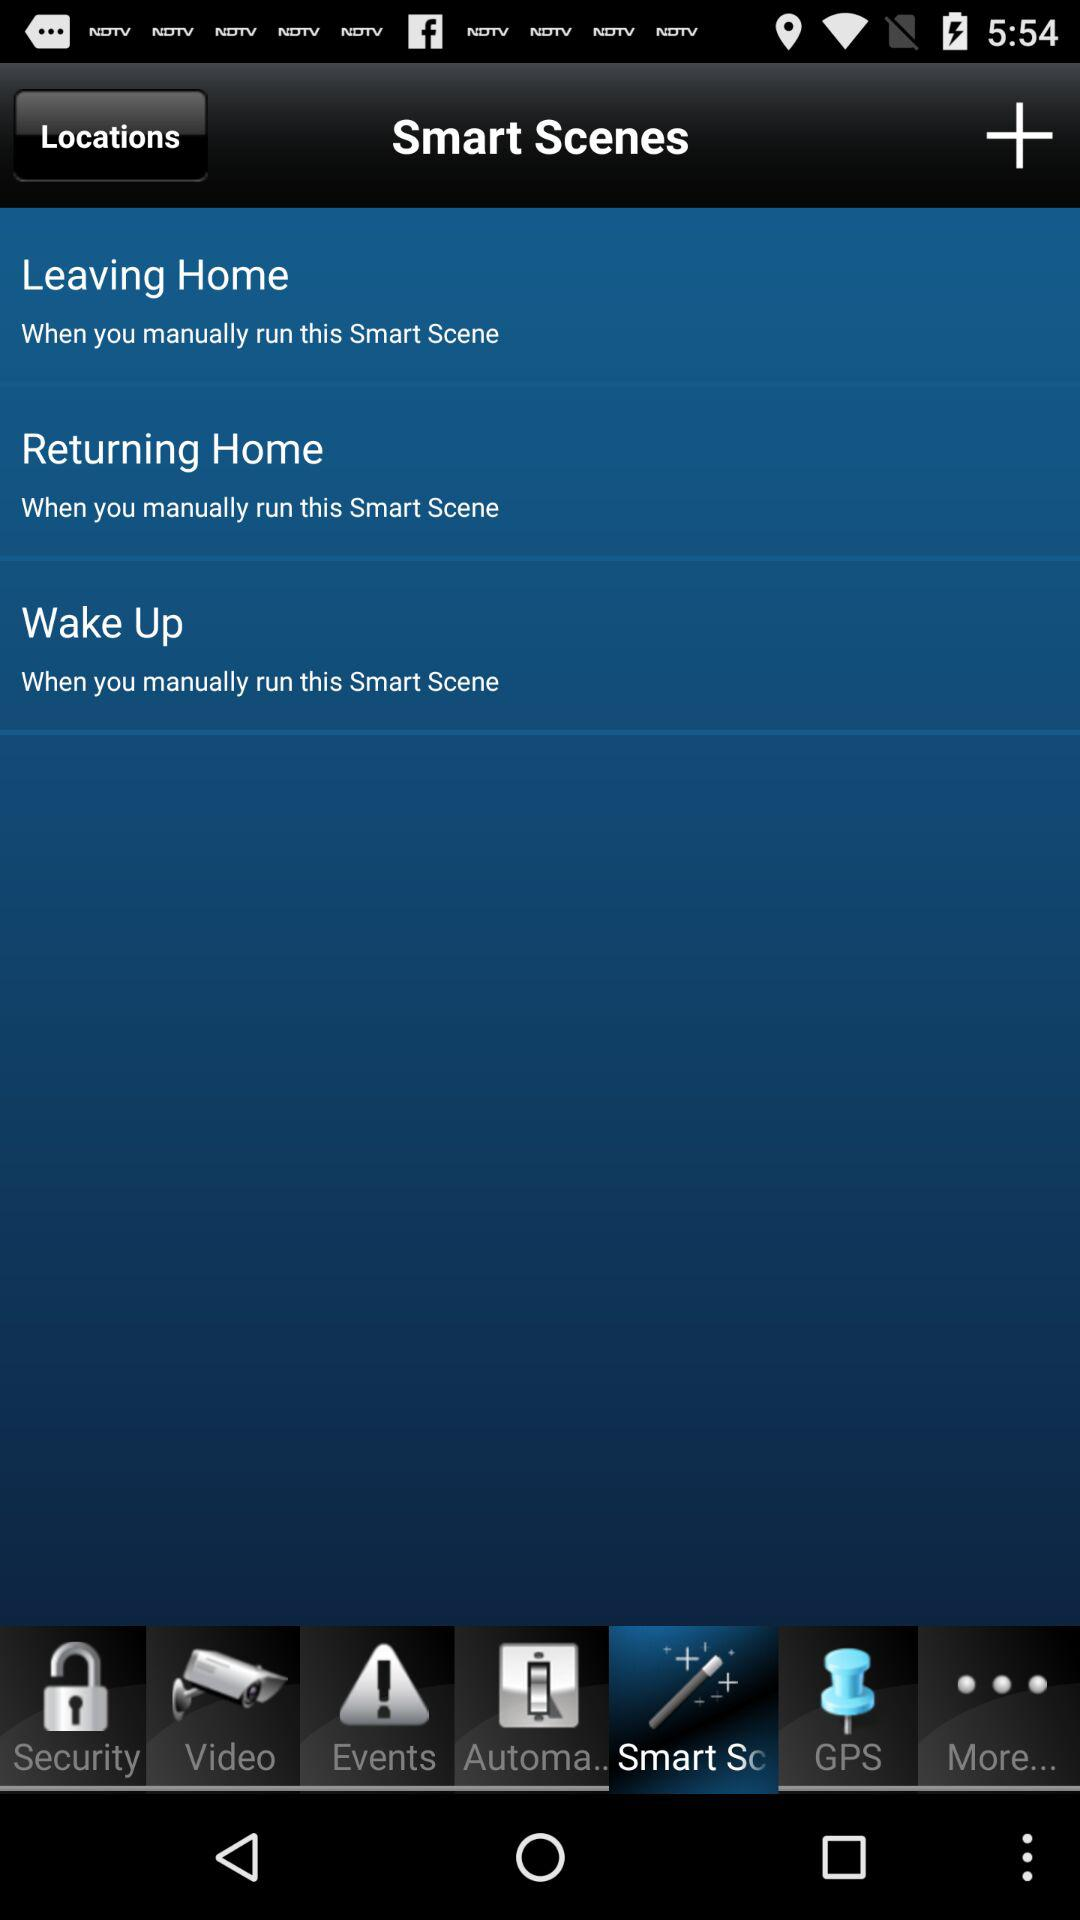How many smart scenes are there?
Answer the question using a single word or phrase. 3 